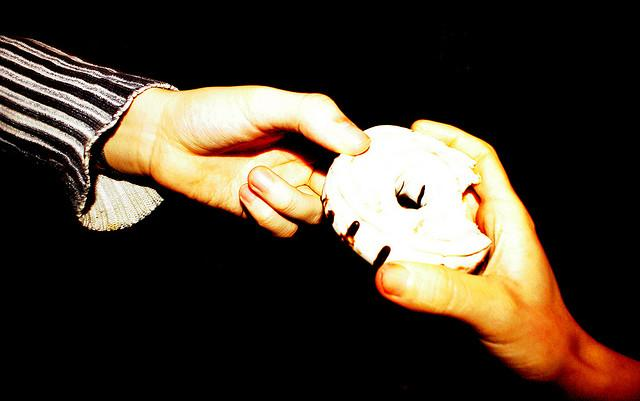Which person bit the donut? Please explain your reasoning. rightmost. Probably the person on the right. 